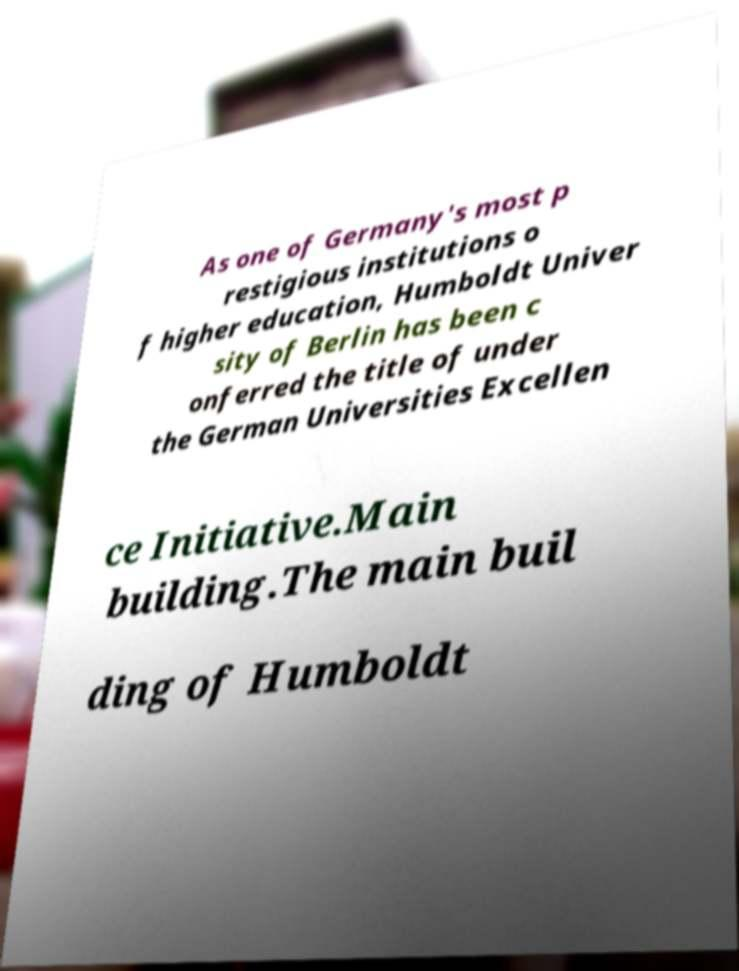Please identify and transcribe the text found in this image. As one of Germany's most p restigious institutions o f higher education, Humboldt Univer sity of Berlin has been c onferred the title of under the German Universities Excellen ce Initiative.Main building.The main buil ding of Humboldt 